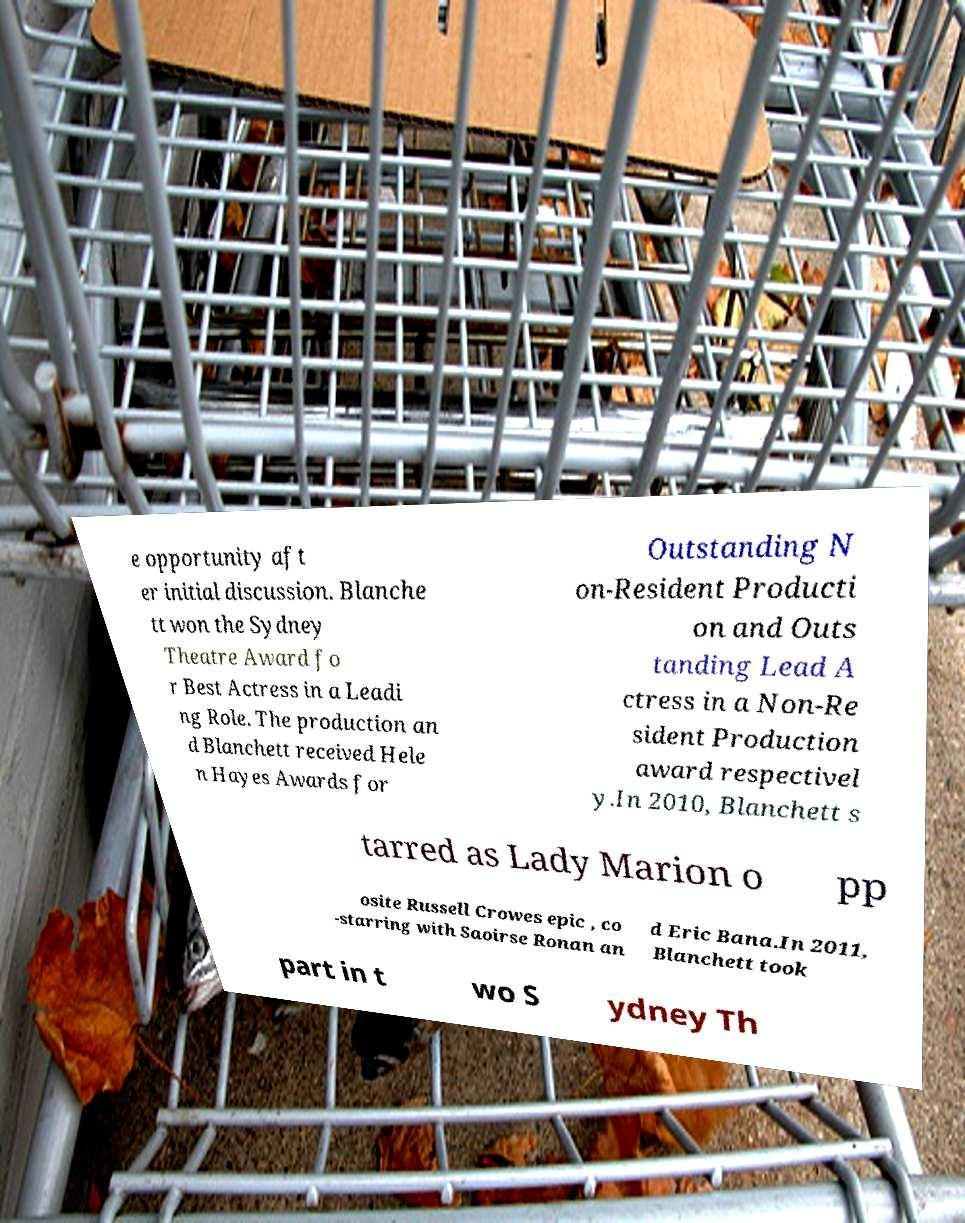For documentation purposes, I need the text within this image transcribed. Could you provide that? e opportunity aft er initial discussion. Blanche tt won the Sydney Theatre Award fo r Best Actress in a Leadi ng Role. The production an d Blanchett received Hele n Hayes Awards for Outstanding N on-Resident Producti on and Outs tanding Lead A ctress in a Non-Re sident Production award respectivel y.In 2010, Blanchett s tarred as Lady Marion o pp osite Russell Crowes epic , co -starring with Saoirse Ronan an d Eric Bana.In 2011, Blanchett took part in t wo S ydney Th 